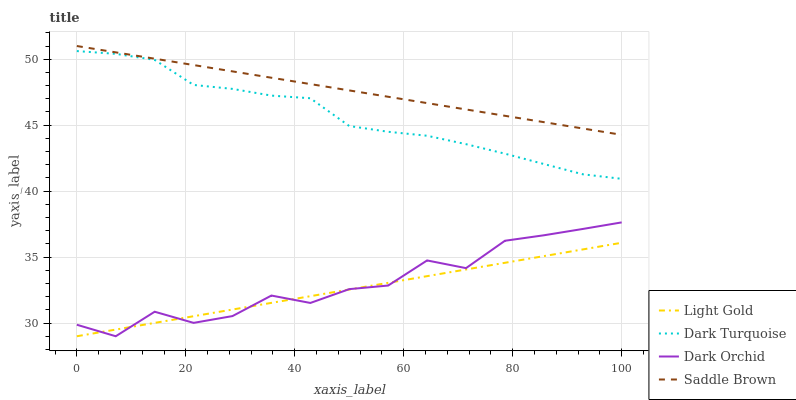Does Light Gold have the minimum area under the curve?
Answer yes or no. Yes. Does Saddle Brown have the maximum area under the curve?
Answer yes or no. Yes. Does Saddle Brown have the minimum area under the curve?
Answer yes or no. No. Does Light Gold have the maximum area under the curve?
Answer yes or no. No. Is Saddle Brown the smoothest?
Answer yes or no. Yes. Is Dark Orchid the roughest?
Answer yes or no. Yes. Is Light Gold the smoothest?
Answer yes or no. No. Is Light Gold the roughest?
Answer yes or no. No. Does Light Gold have the lowest value?
Answer yes or no. Yes. Does Saddle Brown have the lowest value?
Answer yes or no. No. Does Saddle Brown have the highest value?
Answer yes or no. Yes. Does Light Gold have the highest value?
Answer yes or no. No. Is Light Gold less than Dark Turquoise?
Answer yes or no. Yes. Is Dark Turquoise greater than Light Gold?
Answer yes or no. Yes. Does Light Gold intersect Dark Orchid?
Answer yes or no. Yes. Is Light Gold less than Dark Orchid?
Answer yes or no. No. Is Light Gold greater than Dark Orchid?
Answer yes or no. No. Does Light Gold intersect Dark Turquoise?
Answer yes or no. No. 